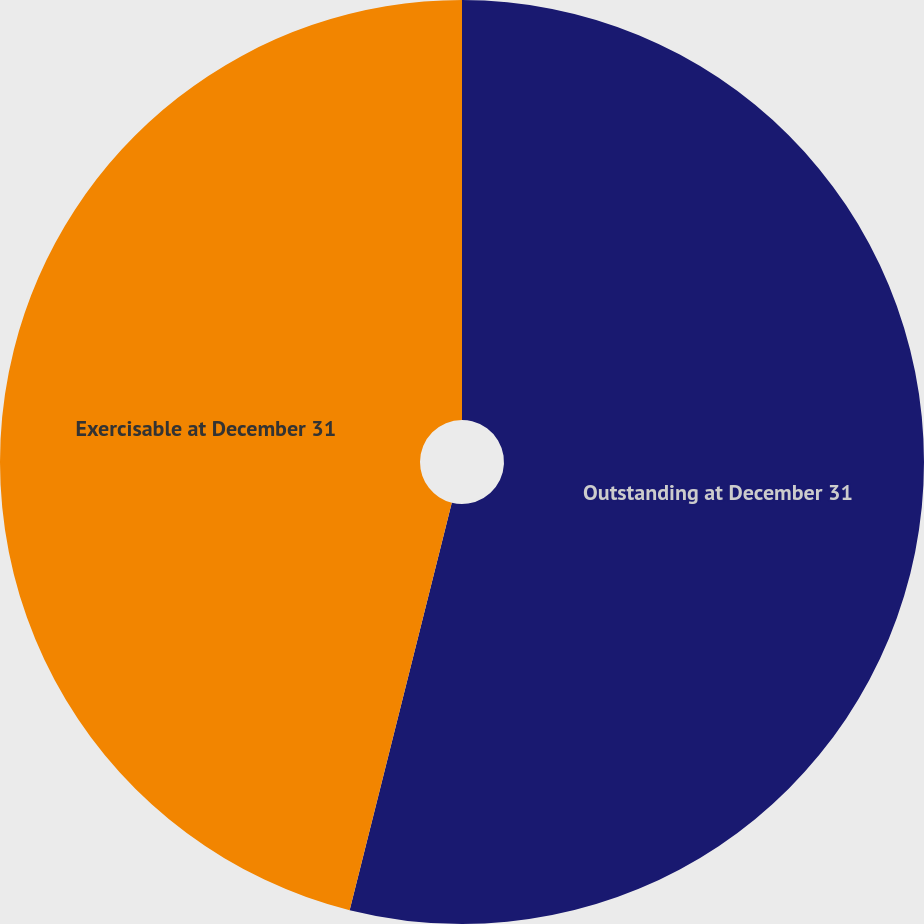Convert chart to OTSL. <chart><loc_0><loc_0><loc_500><loc_500><pie_chart><fcel>Outstanding at December 31<fcel>Exercisable at December 31<nl><fcel>53.91%<fcel>46.09%<nl></chart> 